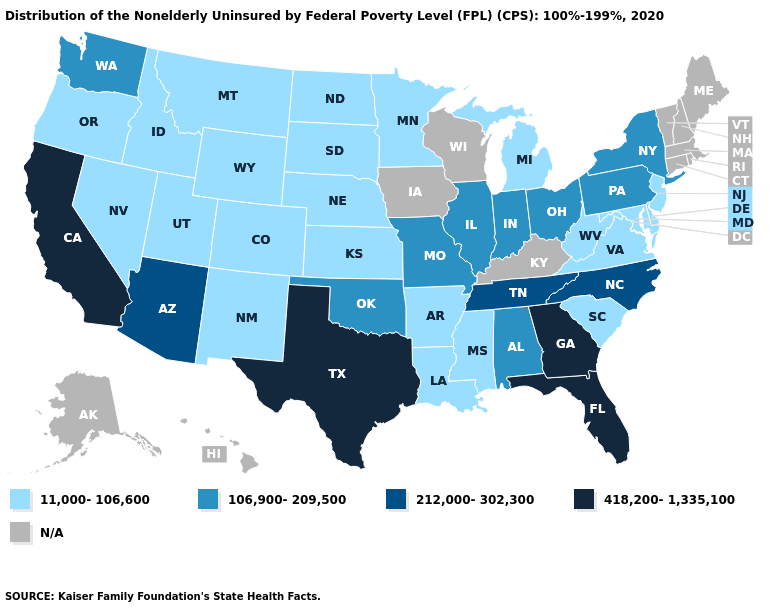What is the value of Georgia?
Quick response, please. 418,200-1,335,100. What is the lowest value in the USA?
Give a very brief answer. 11,000-106,600. What is the lowest value in the USA?
Quick response, please. 11,000-106,600. Which states have the lowest value in the MidWest?
Concise answer only. Kansas, Michigan, Minnesota, Nebraska, North Dakota, South Dakota. Name the states that have a value in the range N/A?
Write a very short answer. Alaska, Connecticut, Hawaii, Iowa, Kentucky, Maine, Massachusetts, New Hampshire, Rhode Island, Vermont, Wisconsin. Among the states that border New Jersey , does Pennsylvania have the lowest value?
Short answer required. No. Which states have the lowest value in the Northeast?
Be succinct. New Jersey. What is the value of Florida?
Give a very brief answer. 418,200-1,335,100. Name the states that have a value in the range 212,000-302,300?
Keep it brief. Arizona, North Carolina, Tennessee. Among the states that border Nevada , which have the highest value?
Be succinct. California. Does North Carolina have the lowest value in the USA?
Short answer required. No. What is the value of Illinois?
Short answer required. 106,900-209,500. Name the states that have a value in the range 212,000-302,300?
Concise answer only. Arizona, North Carolina, Tennessee. 